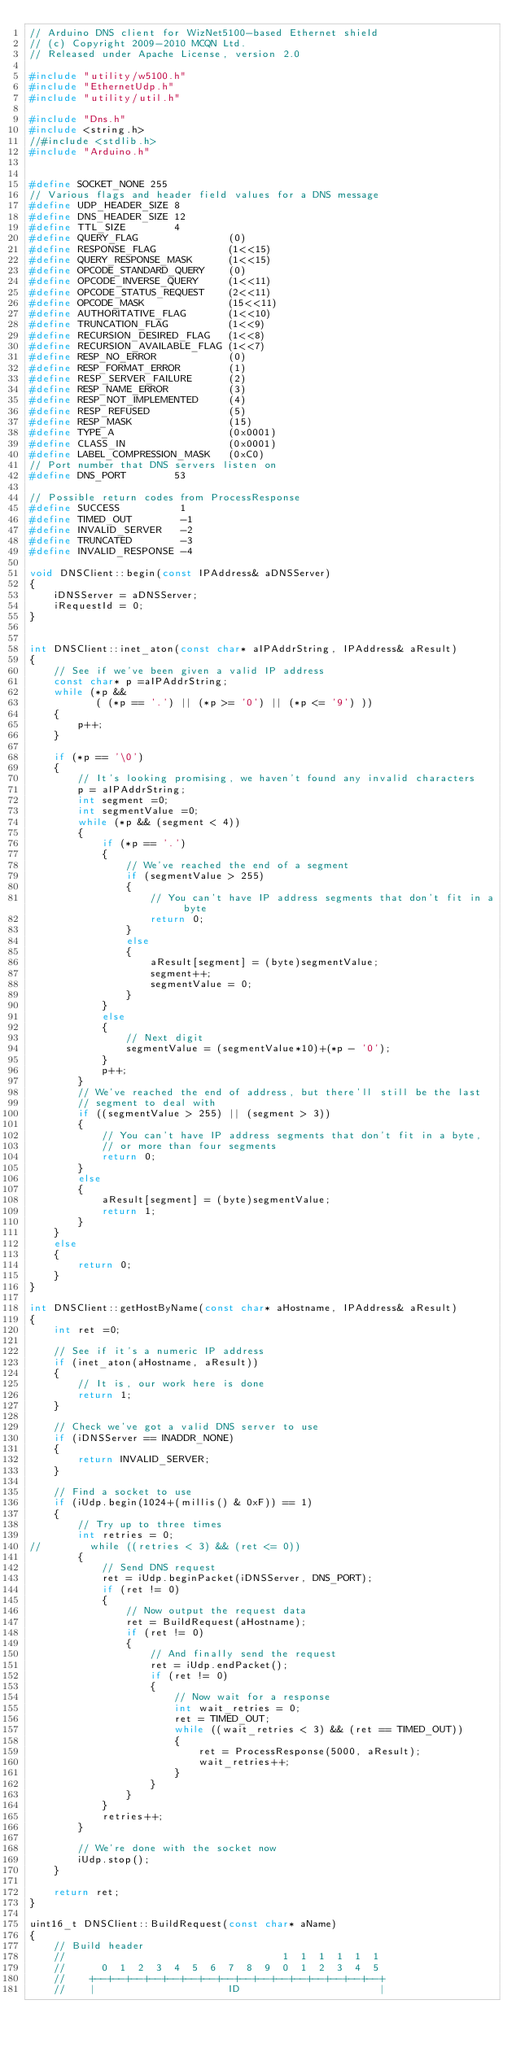<code> <loc_0><loc_0><loc_500><loc_500><_C++_>// Arduino DNS client for WizNet5100-based Ethernet shield
// (c) Copyright 2009-2010 MCQN Ltd.
// Released under Apache License, version 2.0

#include "utility/w5100.h"
#include "EthernetUdp.h"
#include "utility/util.h"

#include "Dns.h"
#include <string.h>
//#include <stdlib.h>
#include "Arduino.h"


#define SOCKET_NONE	255
// Various flags and header field values for a DNS message
#define UDP_HEADER_SIZE	8
#define DNS_HEADER_SIZE	12
#define TTL_SIZE        4
#define QUERY_FLAG               (0)
#define RESPONSE_FLAG            (1<<15)
#define QUERY_RESPONSE_MASK      (1<<15)
#define OPCODE_STANDARD_QUERY    (0)
#define OPCODE_INVERSE_QUERY     (1<<11)
#define OPCODE_STATUS_REQUEST    (2<<11)
#define OPCODE_MASK              (15<<11)
#define AUTHORITATIVE_FLAG       (1<<10)
#define TRUNCATION_FLAG          (1<<9)
#define RECURSION_DESIRED_FLAG   (1<<8)
#define RECURSION_AVAILABLE_FLAG (1<<7)
#define RESP_NO_ERROR            (0)
#define RESP_FORMAT_ERROR        (1)
#define RESP_SERVER_FAILURE      (2)
#define RESP_NAME_ERROR          (3)
#define RESP_NOT_IMPLEMENTED     (4)
#define RESP_REFUSED             (5)
#define RESP_MASK                (15)
#define TYPE_A                   (0x0001)
#define CLASS_IN                 (0x0001)
#define LABEL_COMPRESSION_MASK   (0xC0)
// Port number that DNS servers listen on
#define DNS_PORT        53

// Possible return codes from ProcessResponse
#define SUCCESS          1
#define TIMED_OUT        -1
#define INVALID_SERVER   -2
#define TRUNCATED        -3
#define INVALID_RESPONSE -4

void DNSClient::begin(const IPAddress& aDNSServer)
{
    iDNSServer = aDNSServer;
    iRequestId = 0;
}


int DNSClient::inet_aton(const char* aIPAddrString, IPAddress& aResult)
{
    // See if we've been given a valid IP address
    const char* p =aIPAddrString;
    while (*p &&
           ( (*p == '.') || (*p >= '0') || (*p <= '9') ))
    {
        p++;
    }

    if (*p == '\0')
    {
        // It's looking promising, we haven't found any invalid characters
        p = aIPAddrString;
        int segment =0;
        int segmentValue =0;
        while (*p && (segment < 4))
        {
            if (*p == '.')
            {
                // We've reached the end of a segment
                if (segmentValue > 255)
                {
                    // You can't have IP address segments that don't fit in a byte
                    return 0;
                }
                else
                {
                    aResult[segment] = (byte)segmentValue;
                    segment++;
                    segmentValue = 0;
                }
            }
            else
            {
                // Next digit
                segmentValue = (segmentValue*10)+(*p - '0');
            }
            p++;
        }
        // We've reached the end of address, but there'll still be the last
        // segment to deal with
        if ((segmentValue > 255) || (segment > 3))
        {
            // You can't have IP address segments that don't fit in a byte,
            // or more than four segments
            return 0;
        }
        else
        {
            aResult[segment] = (byte)segmentValue;
            return 1;
        }
    }
    else
    {
        return 0;
    }
}

int DNSClient::getHostByName(const char* aHostname, IPAddress& aResult)
{
    int ret =0;

    // See if it's a numeric IP address
    if (inet_aton(aHostname, aResult))
    {
        // It is, our work here is done
        return 1;
    }

    // Check we've got a valid DNS server to use
    if (iDNSServer == INADDR_NONE)
    {
        return INVALID_SERVER;
    }
	
    // Find a socket to use
    if (iUdp.begin(1024+(millis() & 0xF)) == 1)
    {
        // Try up to three times
        int retries = 0;
//        while ((retries < 3) && (ret <= 0))
        {
            // Send DNS request
            ret = iUdp.beginPacket(iDNSServer, DNS_PORT);
            if (ret != 0)
            {
                // Now output the request data
                ret = BuildRequest(aHostname);
                if (ret != 0)
                {
                    // And finally send the request
                    ret = iUdp.endPacket();
                    if (ret != 0)
                    {
                        // Now wait for a response
                        int wait_retries = 0;
                        ret = TIMED_OUT;
                        while ((wait_retries < 3) && (ret == TIMED_OUT))
                        {
                            ret = ProcessResponse(5000, aResult);
                            wait_retries++;
                        }
                    }
                }
            }
            retries++;
        }

        // We're done with the socket now
        iUdp.stop();
    }

    return ret;
}

uint16_t DNSClient::BuildRequest(const char* aName)
{
    // Build header
    //                                    1  1  1  1  1  1
    //      0  1  2  3  4  5  6  7  8  9  0  1  2  3  4  5
    //    +--+--+--+--+--+--+--+--+--+--+--+--+--+--+--+--+
    //    |                      ID                       |</code> 